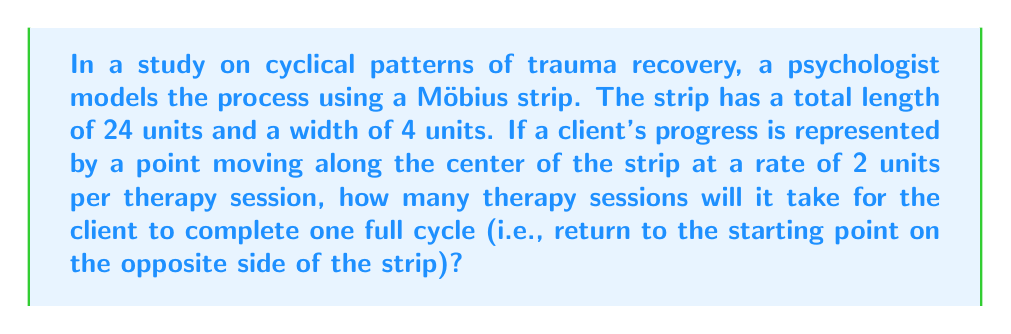Solve this math problem. To solve this problem, we need to understand the properties of a Möbius strip and how it relates to the cyclical nature of trauma recovery:

1) A Möbius strip is a surface with only one side and one edge. It can be created by taking a strip of paper, giving it a half-twist, and then joining the ends.

2) The length of the path along the center of the Möbius strip is equal to the total length of the strip. In this case, it's 24 units.

3) After one complete cycle, a point on a Möbius strip returns to its starting position but on the opposite side of the strip.

Now, let's calculate:

1) The distance the client needs to travel for one complete cycle is the full length of the strip: 24 units.

2) The client moves at a rate of 2 units per therapy session.

3) To find the number of sessions, we use the formula:
   
   $$\text{Number of sessions} = \frac{\text{Total distance}}{\text{Distance per session}}$$

4) Plugging in our values:

   $$\text{Number of sessions} = \frac{24 \text{ units}}{2 \text{ units/session}} = 12 \text{ sessions}$$

This result aligns with the concept of cyclical patterns in trauma recovery, where a client might feel they've returned to the starting point, but they've actually made progress (now on the opposite side of the strip).
Answer: 12 sessions 